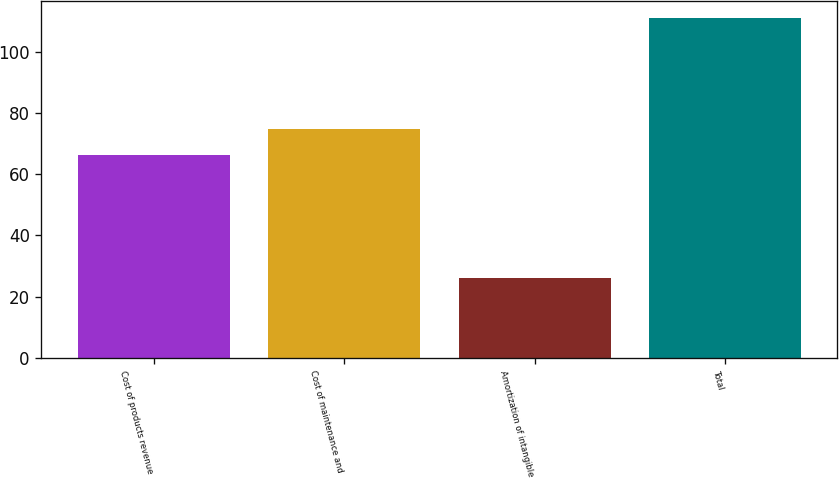Convert chart to OTSL. <chart><loc_0><loc_0><loc_500><loc_500><bar_chart><fcel>Cost of products revenue<fcel>Cost of maintenance and<fcel>Amortization of intangible<fcel>Total<nl><fcel>66.3<fcel>74.82<fcel>26<fcel>111.2<nl></chart> 